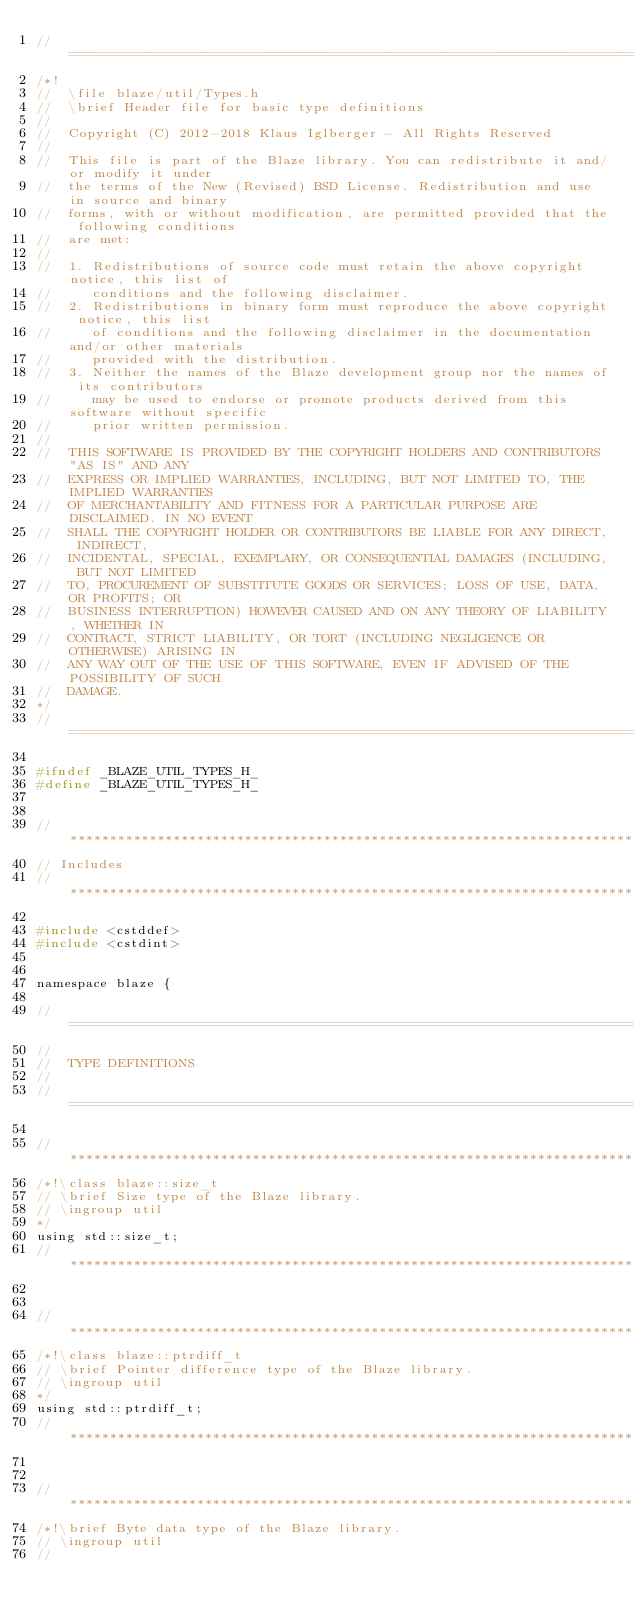<code> <loc_0><loc_0><loc_500><loc_500><_C_>//=================================================================================================
/*!
//  \file blaze/util/Types.h
//  \brief Header file for basic type definitions
//
//  Copyright (C) 2012-2018 Klaus Iglberger - All Rights Reserved
//
//  This file is part of the Blaze library. You can redistribute it and/or modify it under
//  the terms of the New (Revised) BSD License. Redistribution and use in source and binary
//  forms, with or without modification, are permitted provided that the following conditions
//  are met:
//
//  1. Redistributions of source code must retain the above copyright notice, this list of
//     conditions and the following disclaimer.
//  2. Redistributions in binary form must reproduce the above copyright notice, this list
//     of conditions and the following disclaimer in the documentation and/or other materials
//     provided with the distribution.
//  3. Neither the names of the Blaze development group nor the names of its contributors
//     may be used to endorse or promote products derived from this software without specific
//     prior written permission.
//
//  THIS SOFTWARE IS PROVIDED BY THE COPYRIGHT HOLDERS AND CONTRIBUTORS "AS IS" AND ANY
//  EXPRESS OR IMPLIED WARRANTIES, INCLUDING, BUT NOT LIMITED TO, THE IMPLIED WARRANTIES
//  OF MERCHANTABILITY AND FITNESS FOR A PARTICULAR PURPOSE ARE DISCLAIMED. IN NO EVENT
//  SHALL THE COPYRIGHT HOLDER OR CONTRIBUTORS BE LIABLE FOR ANY DIRECT, INDIRECT,
//  INCIDENTAL, SPECIAL, EXEMPLARY, OR CONSEQUENTIAL DAMAGES (INCLUDING, BUT NOT LIMITED
//  TO, PROCUREMENT OF SUBSTITUTE GOODS OR SERVICES; LOSS OF USE, DATA, OR PROFITS; OR
//  BUSINESS INTERRUPTION) HOWEVER CAUSED AND ON ANY THEORY OF LIABILITY, WHETHER IN
//  CONTRACT, STRICT LIABILITY, OR TORT (INCLUDING NEGLIGENCE OR OTHERWISE) ARISING IN
//  ANY WAY OUT OF THE USE OF THIS SOFTWARE, EVEN IF ADVISED OF THE POSSIBILITY OF SUCH
//  DAMAGE.
*/
//=================================================================================================

#ifndef _BLAZE_UTIL_TYPES_H_
#define _BLAZE_UTIL_TYPES_H_


//*************************************************************************************************
// Includes
//*************************************************************************************************

#include <cstddef>
#include <cstdint>


namespace blaze {

//=================================================================================================
//
//  TYPE DEFINITIONS
//
//=================================================================================================

//*************************************************************************************************
/*!\class blaze::size_t
// \brief Size type of the Blaze library.
// \ingroup util
*/
using std::size_t;
//*************************************************************************************************


//*************************************************************************************************
/*!\class blaze::ptrdiff_t
// \brief Pointer difference type of the Blaze library.
// \ingroup util
*/
using std::ptrdiff_t;
//*************************************************************************************************


//*************************************************************************************************
/*!\brief Byte data type of the Blaze library.
// \ingroup util
//</code> 